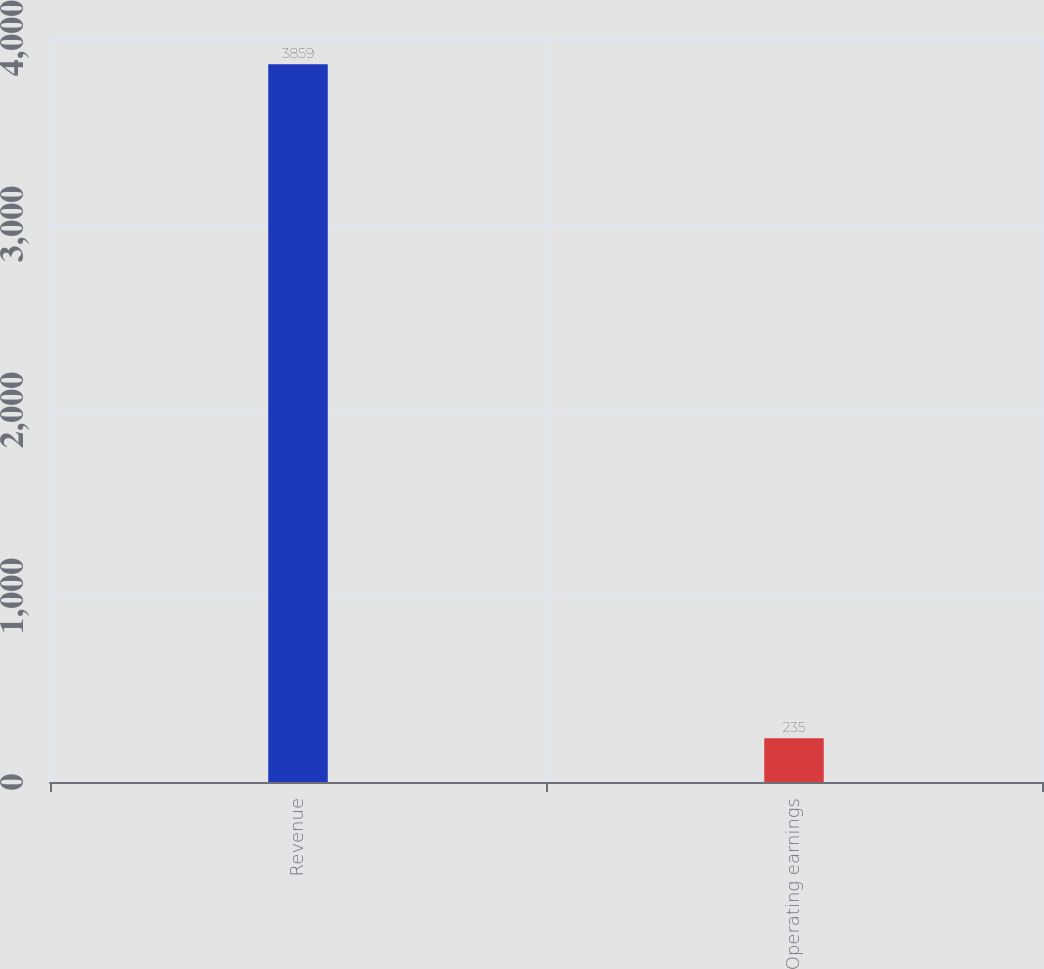<chart> <loc_0><loc_0><loc_500><loc_500><bar_chart><fcel>Revenue<fcel>Operating earnings<nl><fcel>3859<fcel>235<nl></chart> 